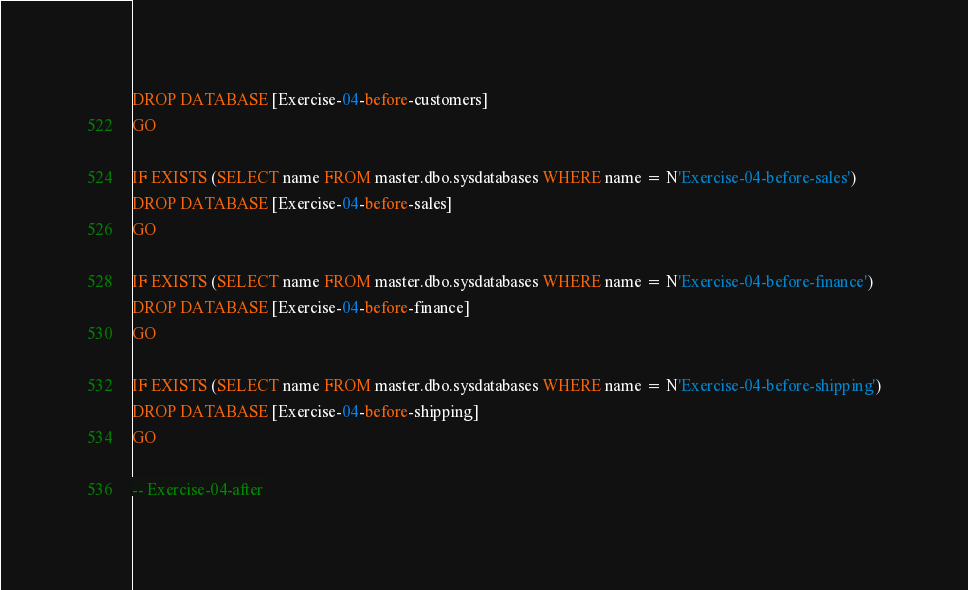Convert code to text. <code><loc_0><loc_0><loc_500><loc_500><_SQL_>DROP DATABASE [Exercise-04-before-customers]
GO

IF EXISTS (SELECT name FROM master.dbo.sysdatabases WHERE name = N'Exercise-04-before-sales')
DROP DATABASE [Exercise-04-before-sales]
GO

IF EXISTS (SELECT name FROM master.dbo.sysdatabases WHERE name = N'Exercise-04-before-finance')
DROP DATABASE [Exercise-04-before-finance]
GO

IF EXISTS (SELECT name FROM master.dbo.sysdatabases WHERE name = N'Exercise-04-before-shipping')
DROP DATABASE [Exercise-04-before-shipping]
GO

-- Exercise-04-after
</code> 